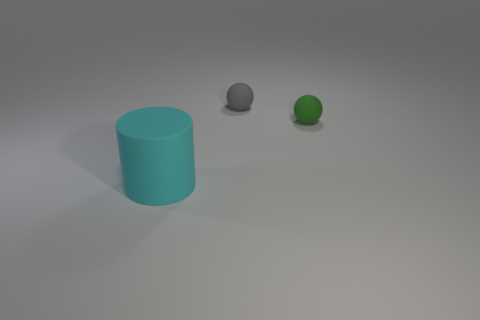Add 3 matte cylinders. How many objects exist? 6 Subtract all gray balls. How many balls are left? 1 Subtract all cylinders. How many objects are left? 2 Subtract 2 balls. How many balls are left? 0 Add 1 matte cylinders. How many matte cylinders are left? 2 Add 1 cyan objects. How many cyan objects exist? 2 Subtract 0 yellow cylinders. How many objects are left? 3 Subtract all brown cylinders. Subtract all green blocks. How many cylinders are left? 1 Subtract all gray things. Subtract all cyan cylinders. How many objects are left? 1 